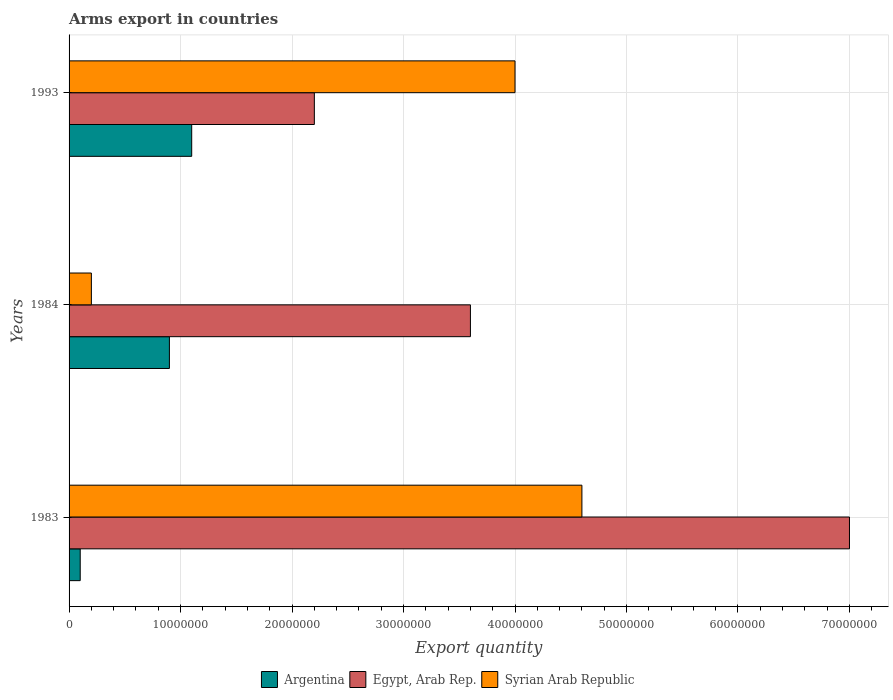How many different coloured bars are there?
Provide a succinct answer. 3. How many groups of bars are there?
Provide a short and direct response. 3. Are the number of bars per tick equal to the number of legend labels?
Provide a succinct answer. Yes. Are the number of bars on each tick of the Y-axis equal?
Your answer should be compact. Yes. How many bars are there on the 2nd tick from the top?
Offer a terse response. 3. How many bars are there on the 1st tick from the bottom?
Make the answer very short. 3. What is the label of the 1st group of bars from the top?
Provide a short and direct response. 1993. In how many cases, is the number of bars for a given year not equal to the number of legend labels?
Give a very brief answer. 0. What is the total arms export in Argentina in 1984?
Offer a terse response. 9.00e+06. Across all years, what is the maximum total arms export in Syrian Arab Republic?
Give a very brief answer. 4.60e+07. Across all years, what is the minimum total arms export in Egypt, Arab Rep.?
Offer a very short reply. 2.20e+07. In which year was the total arms export in Egypt, Arab Rep. minimum?
Your response must be concise. 1993. What is the total total arms export in Argentina in the graph?
Provide a succinct answer. 2.10e+07. What is the difference between the total arms export in Egypt, Arab Rep. in 1983 and that in 1993?
Your response must be concise. 4.80e+07. What is the difference between the total arms export in Egypt, Arab Rep. in 1993 and the total arms export in Syrian Arab Republic in 1984?
Your response must be concise. 2.00e+07. What is the average total arms export in Syrian Arab Republic per year?
Ensure brevity in your answer.  2.93e+07. In the year 1993, what is the difference between the total arms export in Argentina and total arms export in Egypt, Arab Rep.?
Make the answer very short. -1.10e+07. In how many years, is the total arms export in Egypt, Arab Rep. greater than 30000000 ?
Offer a terse response. 2. What is the ratio of the total arms export in Egypt, Arab Rep. in 1983 to that in 1984?
Your response must be concise. 1.94. Is the difference between the total arms export in Argentina in 1983 and 1984 greater than the difference between the total arms export in Egypt, Arab Rep. in 1983 and 1984?
Offer a terse response. No. What is the difference between the highest and the second highest total arms export in Egypt, Arab Rep.?
Your answer should be compact. 3.40e+07. What is the difference between the highest and the lowest total arms export in Argentina?
Your answer should be very brief. 1.00e+07. What does the 2nd bar from the bottom in 1993 represents?
Make the answer very short. Egypt, Arab Rep. How many bars are there?
Keep it short and to the point. 9. Are all the bars in the graph horizontal?
Offer a terse response. Yes. How many years are there in the graph?
Your response must be concise. 3. What is the difference between two consecutive major ticks on the X-axis?
Provide a short and direct response. 1.00e+07. Does the graph contain any zero values?
Your response must be concise. No. Where does the legend appear in the graph?
Your answer should be compact. Bottom center. How many legend labels are there?
Keep it short and to the point. 3. How are the legend labels stacked?
Ensure brevity in your answer.  Horizontal. What is the title of the graph?
Give a very brief answer. Arms export in countries. Does "Low & middle income" appear as one of the legend labels in the graph?
Give a very brief answer. No. What is the label or title of the X-axis?
Provide a short and direct response. Export quantity. What is the Export quantity in Egypt, Arab Rep. in 1983?
Offer a terse response. 7.00e+07. What is the Export quantity in Syrian Arab Republic in 1983?
Offer a terse response. 4.60e+07. What is the Export quantity of Argentina in 1984?
Make the answer very short. 9.00e+06. What is the Export quantity of Egypt, Arab Rep. in 1984?
Give a very brief answer. 3.60e+07. What is the Export quantity of Syrian Arab Republic in 1984?
Provide a succinct answer. 2.00e+06. What is the Export quantity of Argentina in 1993?
Make the answer very short. 1.10e+07. What is the Export quantity in Egypt, Arab Rep. in 1993?
Your answer should be compact. 2.20e+07. What is the Export quantity in Syrian Arab Republic in 1993?
Make the answer very short. 4.00e+07. Across all years, what is the maximum Export quantity of Argentina?
Provide a succinct answer. 1.10e+07. Across all years, what is the maximum Export quantity in Egypt, Arab Rep.?
Ensure brevity in your answer.  7.00e+07. Across all years, what is the maximum Export quantity of Syrian Arab Republic?
Keep it short and to the point. 4.60e+07. Across all years, what is the minimum Export quantity of Argentina?
Provide a short and direct response. 1.00e+06. Across all years, what is the minimum Export quantity of Egypt, Arab Rep.?
Your response must be concise. 2.20e+07. What is the total Export quantity in Argentina in the graph?
Provide a succinct answer. 2.10e+07. What is the total Export quantity of Egypt, Arab Rep. in the graph?
Offer a very short reply. 1.28e+08. What is the total Export quantity of Syrian Arab Republic in the graph?
Your answer should be compact. 8.80e+07. What is the difference between the Export quantity of Argentina in 1983 and that in 1984?
Offer a very short reply. -8.00e+06. What is the difference between the Export quantity in Egypt, Arab Rep. in 1983 and that in 1984?
Your answer should be very brief. 3.40e+07. What is the difference between the Export quantity of Syrian Arab Republic in 1983 and that in 1984?
Keep it short and to the point. 4.40e+07. What is the difference between the Export quantity in Argentina in 1983 and that in 1993?
Make the answer very short. -1.00e+07. What is the difference between the Export quantity in Egypt, Arab Rep. in 1983 and that in 1993?
Keep it short and to the point. 4.80e+07. What is the difference between the Export quantity in Argentina in 1984 and that in 1993?
Your response must be concise. -2.00e+06. What is the difference between the Export quantity of Egypt, Arab Rep. in 1984 and that in 1993?
Offer a very short reply. 1.40e+07. What is the difference between the Export quantity in Syrian Arab Republic in 1984 and that in 1993?
Your response must be concise. -3.80e+07. What is the difference between the Export quantity of Argentina in 1983 and the Export quantity of Egypt, Arab Rep. in 1984?
Your response must be concise. -3.50e+07. What is the difference between the Export quantity in Egypt, Arab Rep. in 1983 and the Export quantity in Syrian Arab Republic in 1984?
Your answer should be very brief. 6.80e+07. What is the difference between the Export quantity of Argentina in 1983 and the Export quantity of Egypt, Arab Rep. in 1993?
Keep it short and to the point. -2.10e+07. What is the difference between the Export quantity in Argentina in 1983 and the Export quantity in Syrian Arab Republic in 1993?
Your answer should be compact. -3.90e+07. What is the difference between the Export quantity in Egypt, Arab Rep. in 1983 and the Export quantity in Syrian Arab Republic in 1993?
Make the answer very short. 3.00e+07. What is the difference between the Export quantity in Argentina in 1984 and the Export quantity in Egypt, Arab Rep. in 1993?
Your answer should be compact. -1.30e+07. What is the difference between the Export quantity in Argentina in 1984 and the Export quantity in Syrian Arab Republic in 1993?
Offer a terse response. -3.10e+07. What is the average Export quantity of Egypt, Arab Rep. per year?
Keep it short and to the point. 4.27e+07. What is the average Export quantity in Syrian Arab Republic per year?
Offer a very short reply. 2.93e+07. In the year 1983, what is the difference between the Export quantity in Argentina and Export quantity in Egypt, Arab Rep.?
Provide a short and direct response. -6.90e+07. In the year 1983, what is the difference between the Export quantity of Argentina and Export quantity of Syrian Arab Republic?
Provide a short and direct response. -4.50e+07. In the year 1983, what is the difference between the Export quantity in Egypt, Arab Rep. and Export quantity in Syrian Arab Republic?
Make the answer very short. 2.40e+07. In the year 1984, what is the difference between the Export quantity in Argentina and Export quantity in Egypt, Arab Rep.?
Provide a short and direct response. -2.70e+07. In the year 1984, what is the difference between the Export quantity of Argentina and Export quantity of Syrian Arab Republic?
Give a very brief answer. 7.00e+06. In the year 1984, what is the difference between the Export quantity in Egypt, Arab Rep. and Export quantity in Syrian Arab Republic?
Your answer should be very brief. 3.40e+07. In the year 1993, what is the difference between the Export quantity in Argentina and Export quantity in Egypt, Arab Rep.?
Your response must be concise. -1.10e+07. In the year 1993, what is the difference between the Export quantity in Argentina and Export quantity in Syrian Arab Republic?
Your response must be concise. -2.90e+07. In the year 1993, what is the difference between the Export quantity in Egypt, Arab Rep. and Export quantity in Syrian Arab Republic?
Your answer should be compact. -1.80e+07. What is the ratio of the Export quantity of Egypt, Arab Rep. in 1983 to that in 1984?
Keep it short and to the point. 1.94. What is the ratio of the Export quantity of Argentina in 1983 to that in 1993?
Keep it short and to the point. 0.09. What is the ratio of the Export quantity in Egypt, Arab Rep. in 1983 to that in 1993?
Keep it short and to the point. 3.18. What is the ratio of the Export quantity of Syrian Arab Republic in 1983 to that in 1993?
Provide a short and direct response. 1.15. What is the ratio of the Export quantity of Argentina in 1984 to that in 1993?
Ensure brevity in your answer.  0.82. What is the ratio of the Export quantity of Egypt, Arab Rep. in 1984 to that in 1993?
Keep it short and to the point. 1.64. What is the difference between the highest and the second highest Export quantity of Argentina?
Offer a terse response. 2.00e+06. What is the difference between the highest and the second highest Export quantity of Egypt, Arab Rep.?
Provide a succinct answer. 3.40e+07. What is the difference between the highest and the second highest Export quantity of Syrian Arab Republic?
Your answer should be compact. 6.00e+06. What is the difference between the highest and the lowest Export quantity in Argentina?
Make the answer very short. 1.00e+07. What is the difference between the highest and the lowest Export quantity of Egypt, Arab Rep.?
Ensure brevity in your answer.  4.80e+07. What is the difference between the highest and the lowest Export quantity of Syrian Arab Republic?
Your response must be concise. 4.40e+07. 